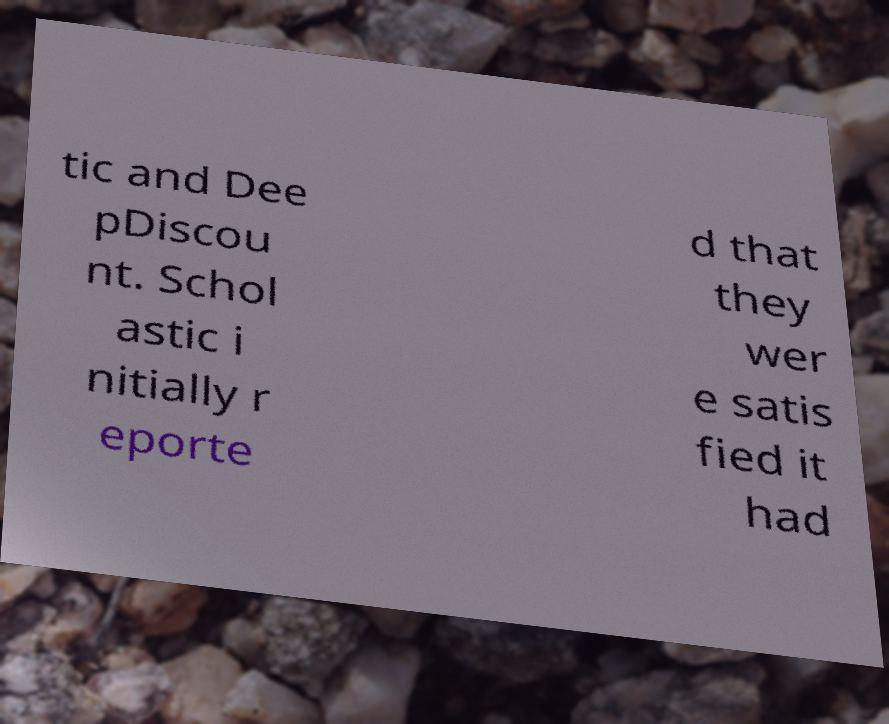Can you read and provide the text displayed in the image?This photo seems to have some interesting text. Can you extract and type it out for me? tic and Dee pDiscou nt. Schol astic i nitially r eporte d that they wer e satis fied it had 